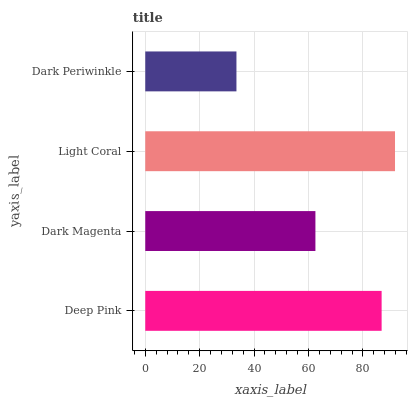Is Dark Periwinkle the minimum?
Answer yes or no. Yes. Is Light Coral the maximum?
Answer yes or no. Yes. Is Dark Magenta the minimum?
Answer yes or no. No. Is Dark Magenta the maximum?
Answer yes or no. No. Is Deep Pink greater than Dark Magenta?
Answer yes or no. Yes. Is Dark Magenta less than Deep Pink?
Answer yes or no. Yes. Is Dark Magenta greater than Deep Pink?
Answer yes or no. No. Is Deep Pink less than Dark Magenta?
Answer yes or no. No. Is Deep Pink the high median?
Answer yes or no. Yes. Is Dark Magenta the low median?
Answer yes or no. Yes. Is Light Coral the high median?
Answer yes or no. No. Is Light Coral the low median?
Answer yes or no. No. 